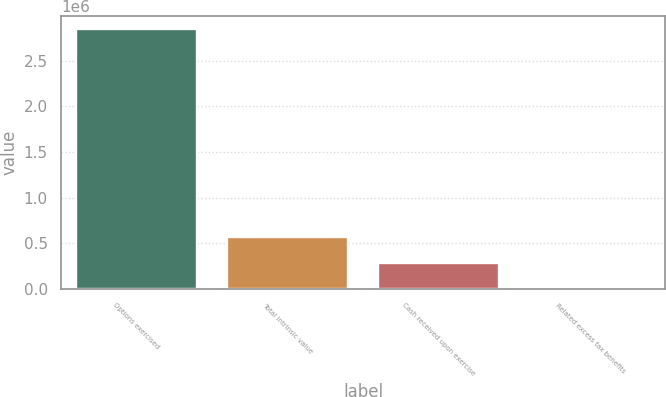<chart> <loc_0><loc_0><loc_500><loc_500><bar_chart><fcel>Options exercised<fcel>Total intrinsic value<fcel>Cash received upon exercise<fcel>Related excess tax benefits<nl><fcel>2.84568e+06<fcel>569169<fcel>284606<fcel>42<nl></chart> 